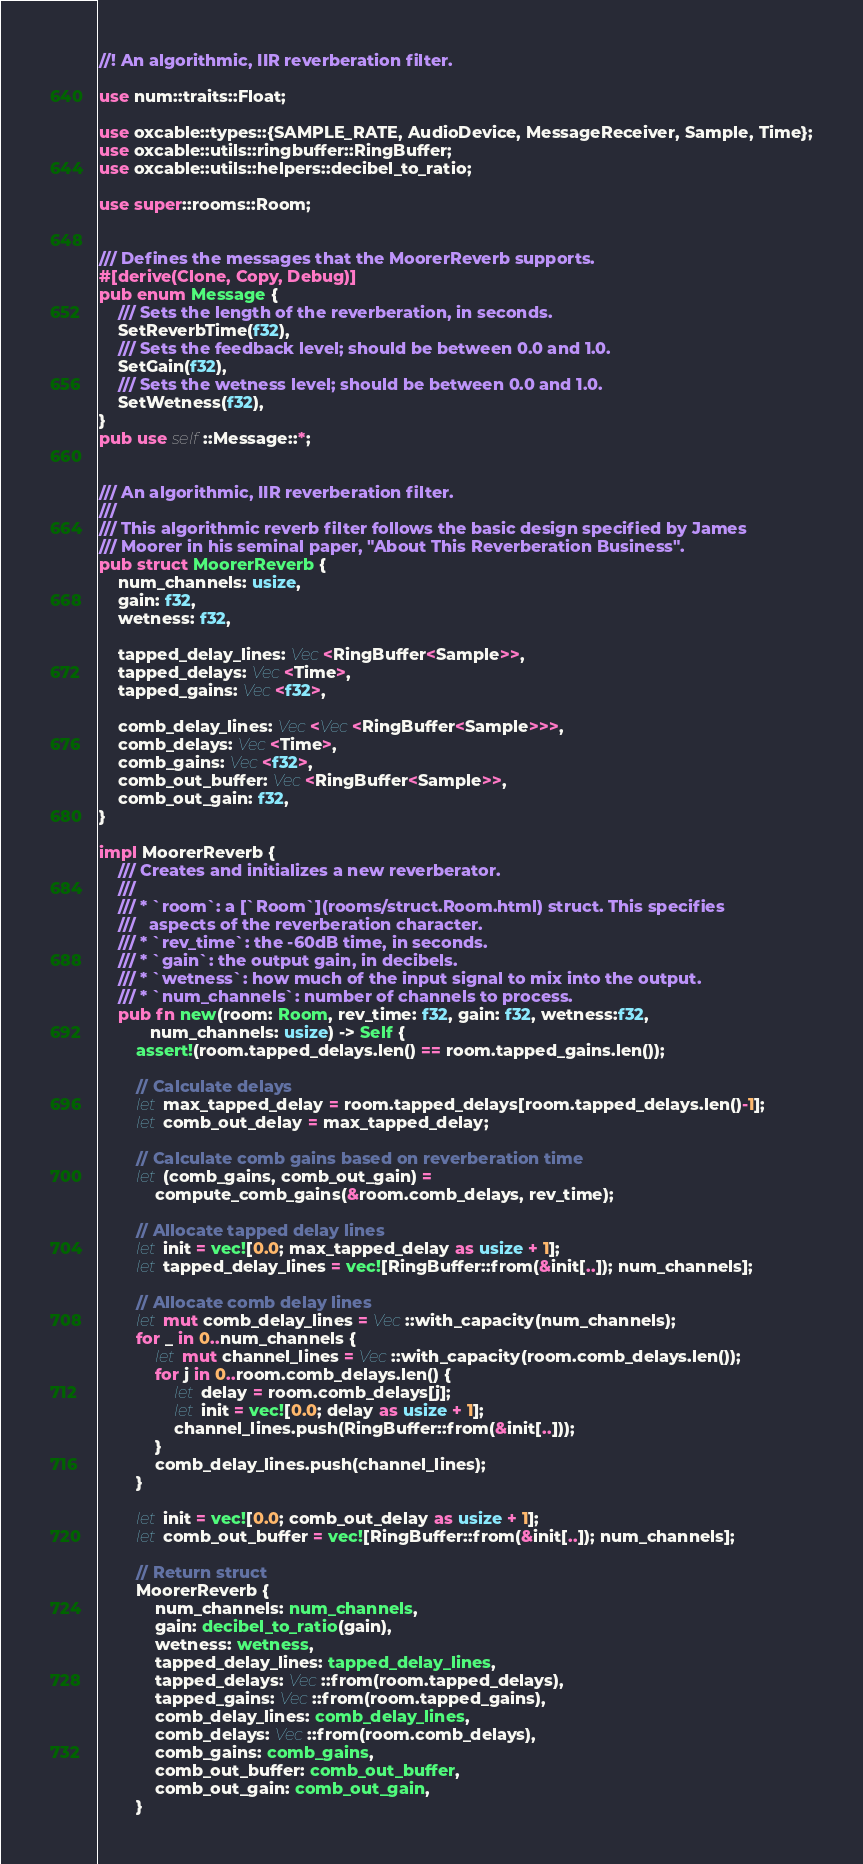Convert code to text. <code><loc_0><loc_0><loc_500><loc_500><_Rust_>//! An algorithmic, IIR reverberation filter.

use num::traits::Float;

use oxcable::types::{SAMPLE_RATE, AudioDevice, MessageReceiver, Sample, Time};
use oxcable::utils::ringbuffer::RingBuffer;
use oxcable::utils::helpers::decibel_to_ratio;

use super::rooms::Room;


/// Defines the messages that the MoorerReverb supports.
#[derive(Clone, Copy, Debug)]
pub enum Message {
    /// Sets the length of the reverberation, in seconds.
    SetReverbTime(f32),
    /// Sets the feedback level; should be between 0.0 and 1.0.
    SetGain(f32),
    /// Sets the wetness level; should be between 0.0 and 1.0.
    SetWetness(f32),
}
pub use self::Message::*;


/// An algorithmic, IIR reverberation filter.
///
/// This algorithmic reverb filter follows the basic design specified by James
/// Moorer in his seminal paper, "About This Reverberation Business".
pub struct MoorerReverb {
    num_channels: usize,
    gain: f32,
    wetness: f32,

    tapped_delay_lines: Vec<RingBuffer<Sample>>,
    tapped_delays: Vec<Time>,
    tapped_gains: Vec<f32>,

    comb_delay_lines: Vec<Vec<RingBuffer<Sample>>>,
    comb_delays: Vec<Time>,
    comb_gains: Vec<f32>,
    comb_out_buffer: Vec<RingBuffer<Sample>>,
    comb_out_gain: f32,
}

impl MoorerReverb {
    /// Creates and initializes a new reverberator.
    ///
    /// * `room`: a [`Room`](rooms/struct.Room.html) struct. This specifies
    ///   aspects of the reverberation character.
    /// * `rev_time`: the -60dB time, in seconds.
    /// * `gain`: the output gain, in decibels.
    /// * `wetness`: how much of the input signal to mix into the output.
    /// * `num_channels`: number of channels to process.
    pub fn new(room: Room, rev_time: f32, gain: f32, wetness:f32,
           num_channels: usize) -> Self {
        assert!(room.tapped_delays.len() == room.tapped_gains.len());

        // Calculate delays
        let max_tapped_delay = room.tapped_delays[room.tapped_delays.len()-1];
        let comb_out_delay = max_tapped_delay;

        // Calculate comb gains based on reverberation time
        let (comb_gains, comb_out_gain) =
            compute_comb_gains(&room.comb_delays, rev_time);

        // Allocate tapped delay lines
        let init = vec![0.0; max_tapped_delay as usize + 1];
        let tapped_delay_lines = vec![RingBuffer::from(&init[..]); num_channels];

        // Allocate comb delay lines
        let mut comb_delay_lines = Vec::with_capacity(num_channels);
        for _ in 0..num_channels {
            let mut channel_lines = Vec::with_capacity(room.comb_delays.len());
            for j in 0..room.comb_delays.len() {
                let delay = room.comb_delays[j];
                let init = vec![0.0; delay as usize + 1];
                channel_lines.push(RingBuffer::from(&init[..]));
            }
            comb_delay_lines.push(channel_lines);
        }

        let init = vec![0.0; comb_out_delay as usize + 1];
        let comb_out_buffer = vec![RingBuffer::from(&init[..]); num_channels];

        // Return struct
        MoorerReverb {
            num_channels: num_channels,
            gain: decibel_to_ratio(gain),
            wetness: wetness,
            tapped_delay_lines: tapped_delay_lines,
            tapped_delays: Vec::from(room.tapped_delays),
            tapped_gains: Vec::from(room.tapped_gains),
            comb_delay_lines: comb_delay_lines,
            comb_delays: Vec::from(room.comb_delays),
            comb_gains: comb_gains,
            comb_out_buffer: comb_out_buffer,
            comb_out_gain: comb_out_gain,
        }</code> 